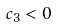Convert formula to latex. <formula><loc_0><loc_0><loc_500><loc_500>c _ { 3 } < 0</formula> 